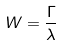<formula> <loc_0><loc_0><loc_500><loc_500>W = \frac { \Gamma } { \lambda }</formula> 